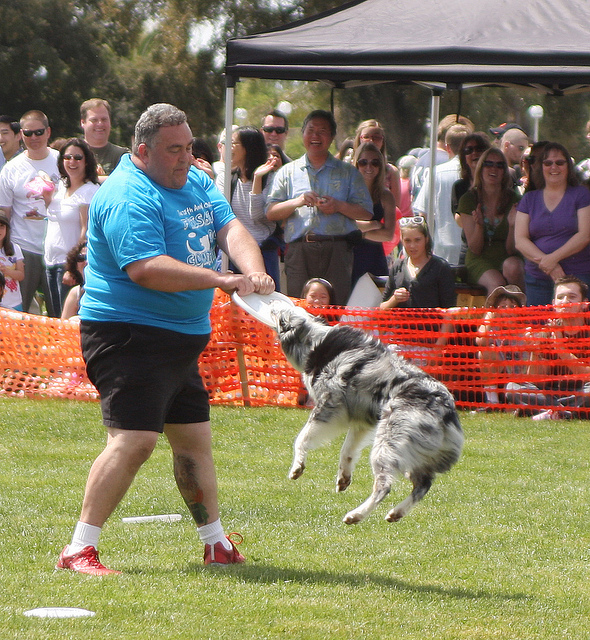Read all the text in this image. South 